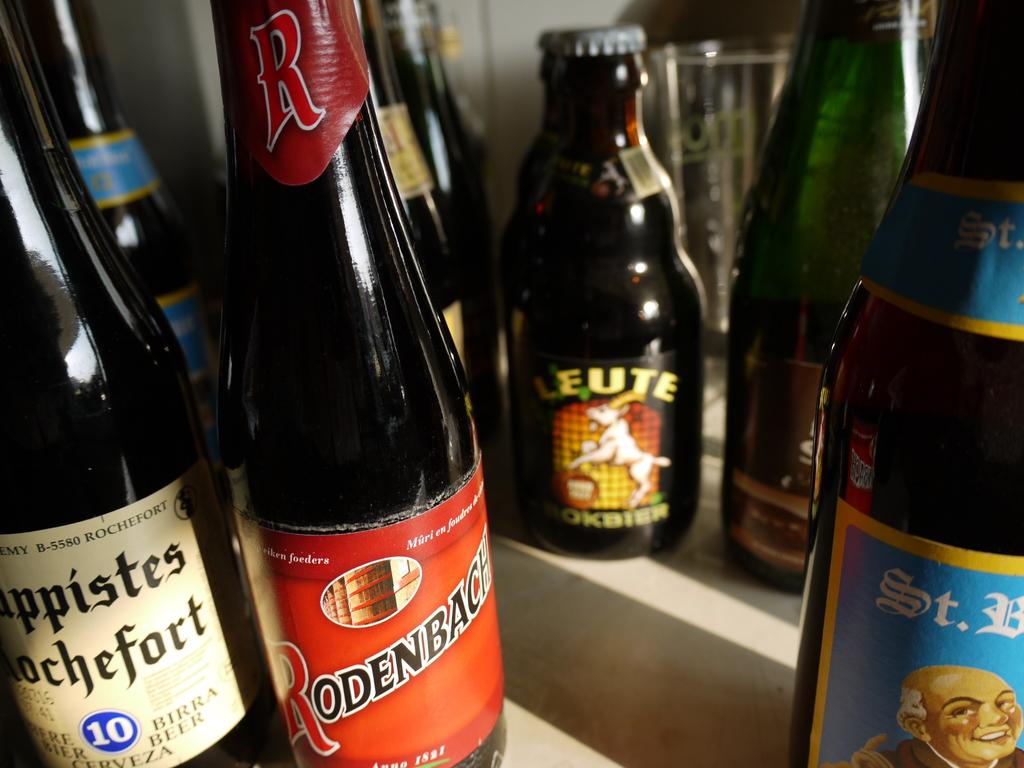What brand of beer is in the bottle in the very back center?
Ensure brevity in your answer.  Leute. 